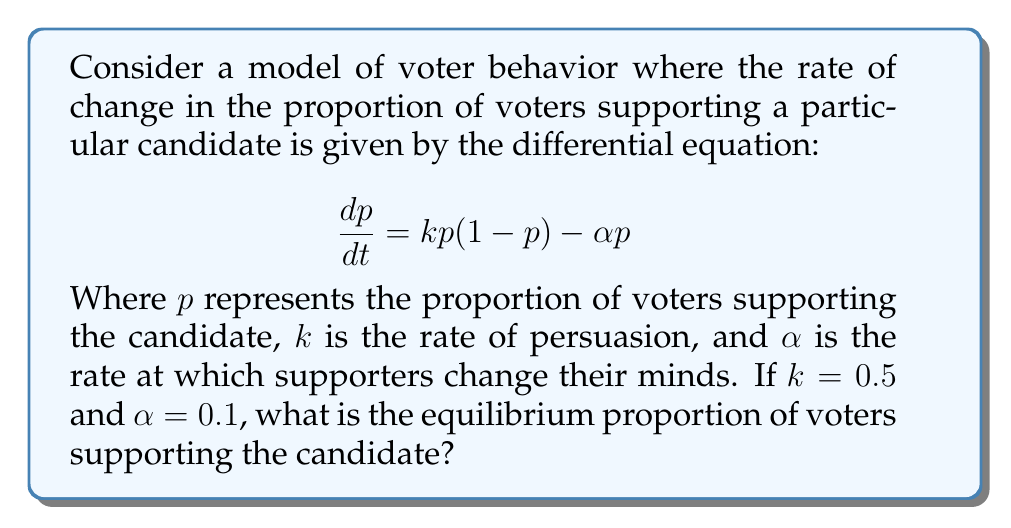Could you help me with this problem? To find the equilibrium proportion of voters, we need to solve for $p$ when $\frac{dp}{dt} = 0$. This gives us:

1) Set the equation equal to zero:
   $$0 = kp(1-p) - \alpha p$$

2) Substitute the given values $k=0.5$ and $\alpha=0.1$:
   $$0 = 0.5p(1-p) - 0.1p$$

3) Expand the equation:
   $$0 = 0.5p - 0.5p^2 - 0.1p$$

4) Combine like terms:
   $$0 = 0.4p - 0.5p^2$$

5) Factor out $p$:
   $$0 = p(0.4 - 0.5p)$$

6) Solve for $p$:
   Either $p = 0$ or $0.4 - 0.5p = 0$
   
   For the non-zero solution:
   $$0.4 = 0.5p$$
   $$p = 0.8$$

7) Check both solutions ($p=0$ and $p=0.8$) in the original equation to confirm they are equilibrium points.

The non-zero equilibrium point $p=0.8$ represents a stable equilibrium where 80% of voters support the candidate.
Answer: $p = 0.8$ or 80% 